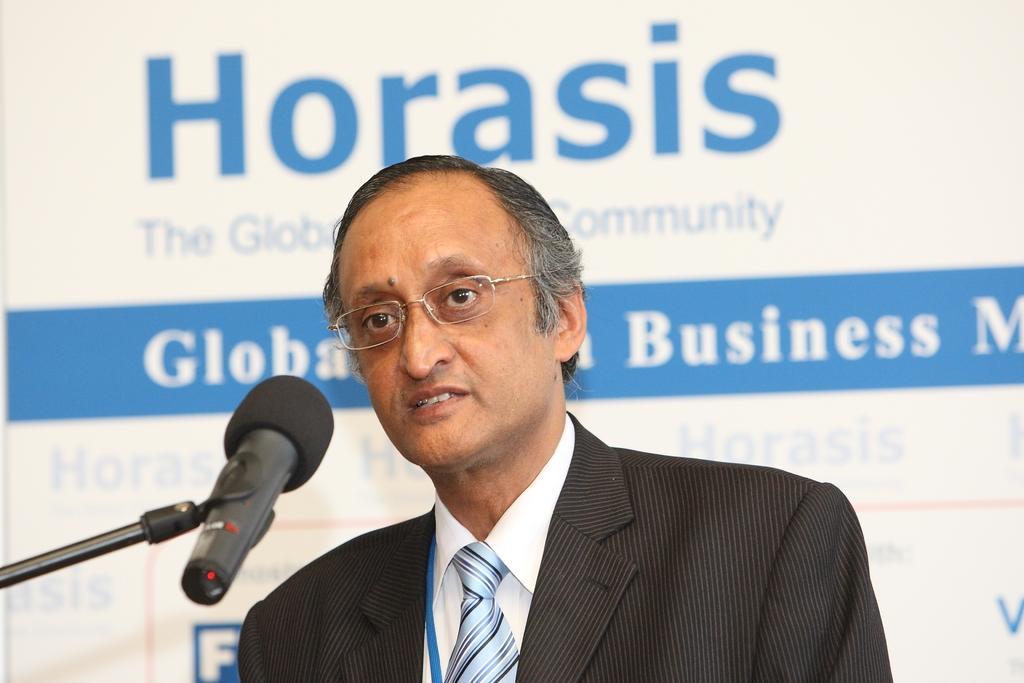Describe this image in one or two sentences. In this picture, we see a man in the white shirt and the black blazer is wearing the spectacles. In front of him, we see a microphone and I think he is talking on the microphone. In the background, we see a banner or a board in white and blue color with some text written on it. 